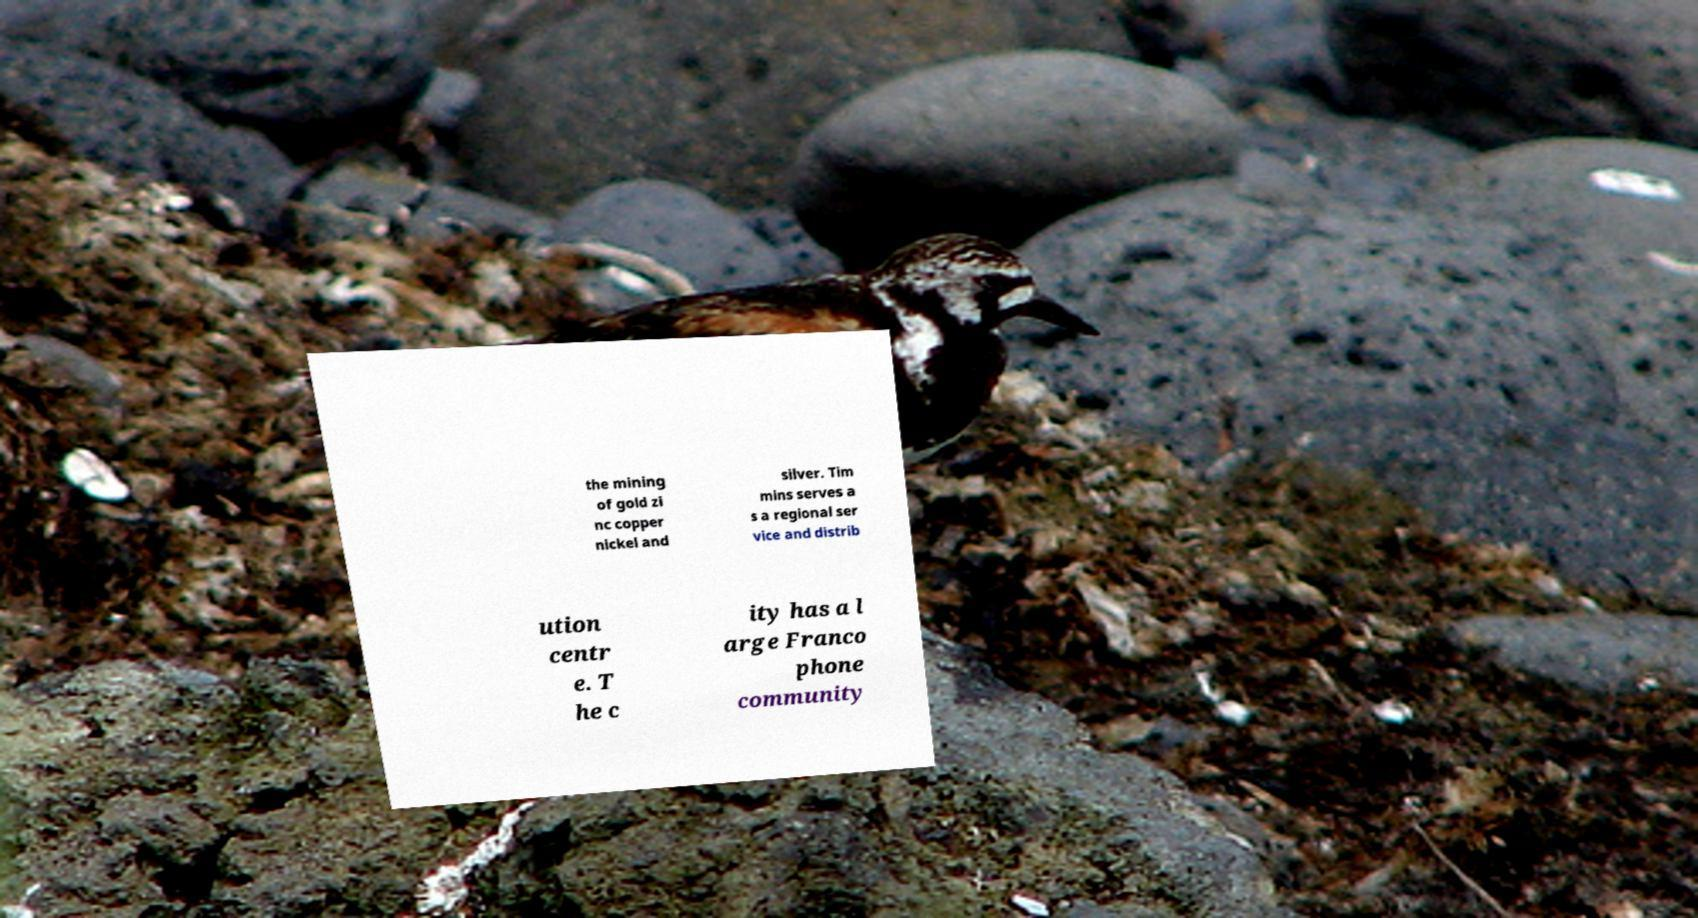Could you extract and type out the text from this image? the mining of gold zi nc copper nickel and silver. Tim mins serves a s a regional ser vice and distrib ution centr e. T he c ity has a l arge Franco phone community 